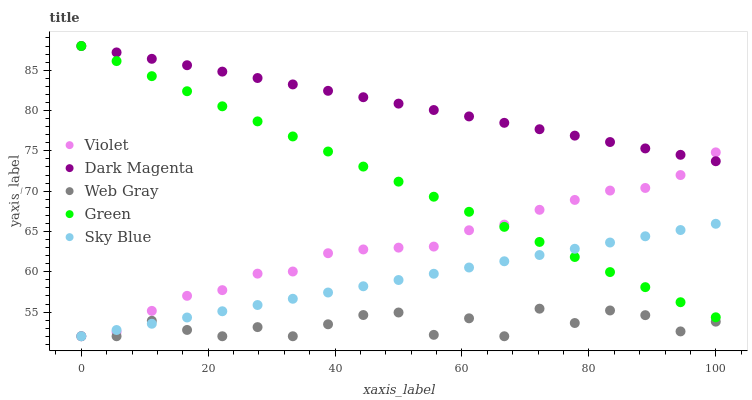Does Web Gray have the minimum area under the curve?
Answer yes or no. Yes. Does Dark Magenta have the maximum area under the curve?
Answer yes or no. Yes. Does Green have the minimum area under the curve?
Answer yes or no. No. Does Green have the maximum area under the curve?
Answer yes or no. No. Is Sky Blue the smoothest?
Answer yes or no. Yes. Is Web Gray the roughest?
Answer yes or no. Yes. Is Green the smoothest?
Answer yes or no. No. Is Green the roughest?
Answer yes or no. No. Does Sky Blue have the lowest value?
Answer yes or no. Yes. Does Green have the lowest value?
Answer yes or no. No. Does Dark Magenta have the highest value?
Answer yes or no. Yes. Does Web Gray have the highest value?
Answer yes or no. No. Is Web Gray less than Dark Magenta?
Answer yes or no. Yes. Is Green greater than Web Gray?
Answer yes or no. Yes. Does Violet intersect Web Gray?
Answer yes or no. Yes. Is Violet less than Web Gray?
Answer yes or no. No. Is Violet greater than Web Gray?
Answer yes or no. No. Does Web Gray intersect Dark Magenta?
Answer yes or no. No. 